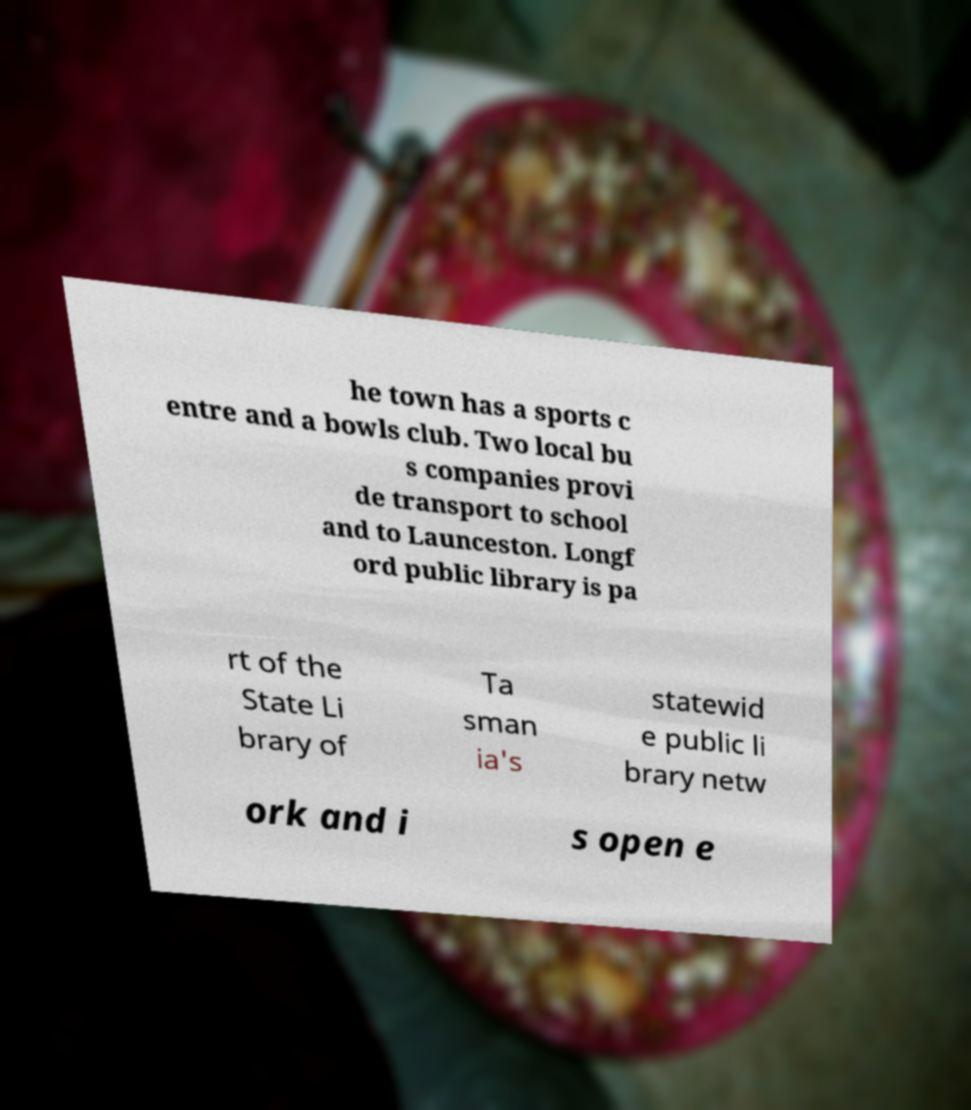There's text embedded in this image that I need extracted. Can you transcribe it verbatim? he town has a sports c entre and a bowls club. Two local bu s companies provi de transport to school and to Launceston. Longf ord public library is pa rt of the State Li brary of Ta sman ia's statewid e public li brary netw ork and i s open e 